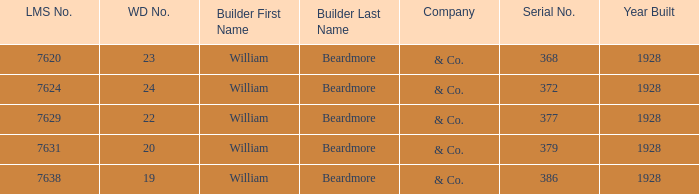Name the builder for serial number being 377 William Beardmore & Co. Give me the full table as a dictionary. {'header': ['LMS No.', 'WD No.', 'Builder First Name', 'Builder Last Name', 'Company', 'Serial No.', 'Year Built'], 'rows': [['7620', '23', 'William', 'Beardmore', '& Co.', '368', '1928'], ['7624', '24', 'William', 'Beardmore', '& Co.', '372', '1928'], ['7629', '22', 'William', 'Beardmore', '& Co.', '377', '1928'], ['7631', '20', 'William', 'Beardmore', '& Co.', '379', '1928'], ['7638', '19', 'William', 'Beardmore', '& Co.', '386', '1928']]} 